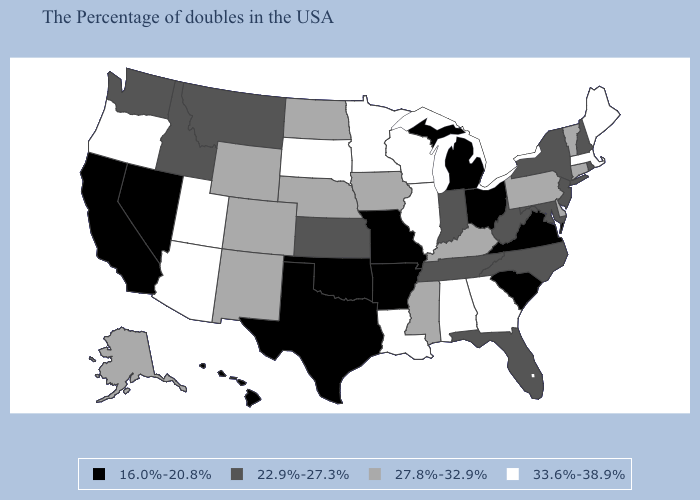Which states hav the highest value in the MidWest?
Keep it brief. Wisconsin, Illinois, Minnesota, South Dakota. Does Illinois have a higher value than South Dakota?
Answer briefly. No. Does Delaware have a higher value than Arkansas?
Give a very brief answer. Yes. Does the map have missing data?
Answer briefly. No. Does North Dakota have the same value as Alaska?
Be succinct. Yes. What is the value of North Carolina?
Keep it brief. 22.9%-27.3%. Name the states that have a value in the range 22.9%-27.3%?
Be succinct. Rhode Island, New Hampshire, New York, New Jersey, Maryland, North Carolina, West Virginia, Florida, Indiana, Tennessee, Kansas, Montana, Idaho, Washington. Is the legend a continuous bar?
Answer briefly. No. Name the states that have a value in the range 22.9%-27.3%?
Answer briefly. Rhode Island, New Hampshire, New York, New Jersey, Maryland, North Carolina, West Virginia, Florida, Indiana, Tennessee, Kansas, Montana, Idaho, Washington. Does Nebraska have the same value as North Dakota?
Keep it brief. Yes. What is the value of Indiana?
Be succinct. 22.9%-27.3%. Name the states that have a value in the range 33.6%-38.9%?
Keep it brief. Maine, Massachusetts, Georgia, Alabama, Wisconsin, Illinois, Louisiana, Minnesota, South Dakota, Utah, Arizona, Oregon. What is the value of Hawaii?
Write a very short answer. 16.0%-20.8%. What is the value of New Mexico?
Be succinct. 27.8%-32.9%. Among the states that border Minnesota , which have the lowest value?
Write a very short answer. Iowa, North Dakota. 